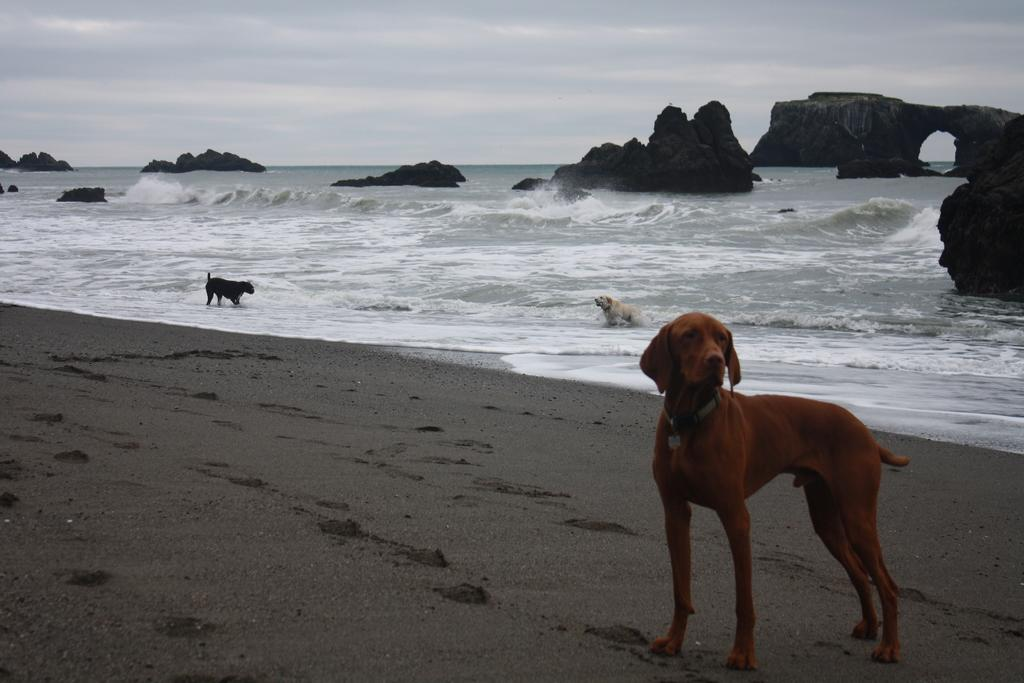What type of animals can be seen in the image? There are animals in the image. What natural setting is visible in the image? There is a sea shore and water visible in the image. What type of terrain can be seen in the image? There are rocks in the image. What is visible in the background of the image? The sky is visible in the background of the image. How many servants are present in the image? There are no servants present in the image. What type of bear can be seen walking on the rocks in the image? There is no bear present in the image, and the animals cannot be identified as bears. 